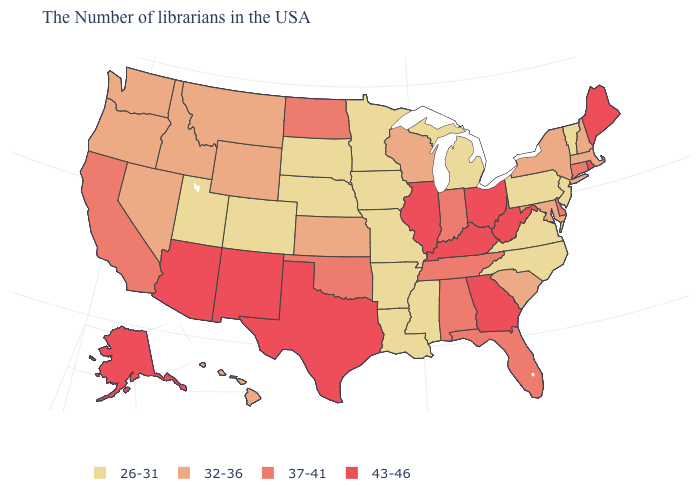Among the states that border Colorado , does Kansas have the lowest value?
Concise answer only. No. What is the value of South Dakota?
Write a very short answer. 26-31. Name the states that have a value in the range 26-31?
Write a very short answer. Vermont, New Jersey, Pennsylvania, Virginia, North Carolina, Michigan, Mississippi, Louisiana, Missouri, Arkansas, Minnesota, Iowa, Nebraska, South Dakota, Colorado, Utah. Does Hawaii have a lower value than Texas?
Keep it brief. Yes. How many symbols are there in the legend?
Concise answer only. 4. Does the first symbol in the legend represent the smallest category?
Be succinct. Yes. Which states have the lowest value in the South?
Keep it brief. Virginia, North Carolina, Mississippi, Louisiana, Arkansas. What is the lowest value in states that border Georgia?
Give a very brief answer. 26-31. Is the legend a continuous bar?
Be succinct. No. Name the states that have a value in the range 43-46?
Keep it brief. Maine, Rhode Island, West Virginia, Ohio, Georgia, Kentucky, Illinois, Texas, New Mexico, Arizona, Alaska. Does Utah have the lowest value in the West?
Concise answer only. Yes. What is the lowest value in the West?
Give a very brief answer. 26-31. What is the value of New York?
Be succinct. 32-36. Name the states that have a value in the range 32-36?
Quick response, please. Massachusetts, New Hampshire, New York, Maryland, South Carolina, Wisconsin, Kansas, Wyoming, Montana, Idaho, Nevada, Washington, Oregon, Hawaii. Does North Dakota have the highest value in the MidWest?
Short answer required. No. 